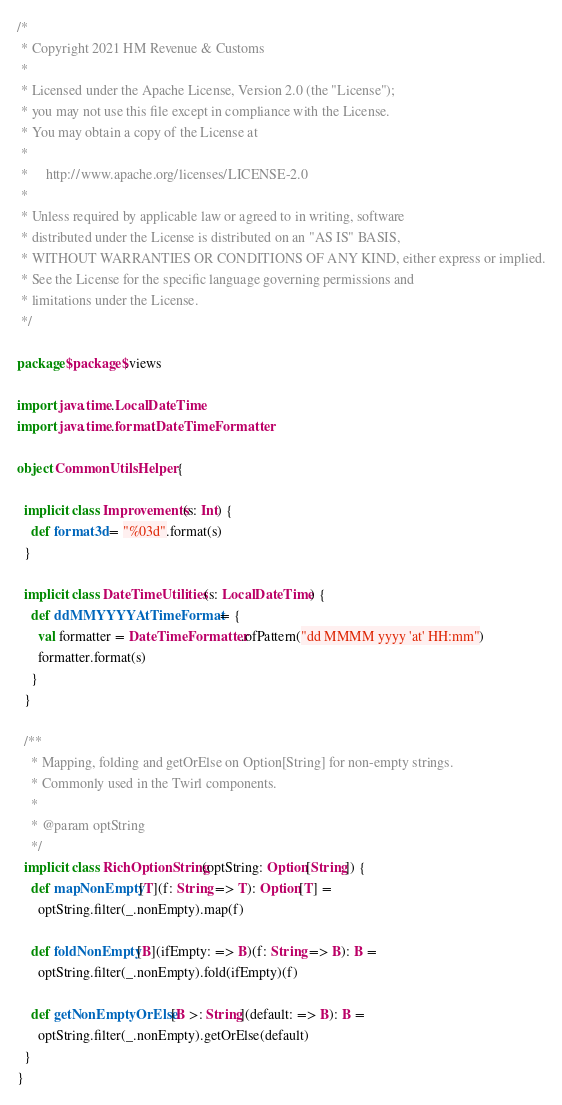Convert code to text. <code><loc_0><loc_0><loc_500><loc_500><_Scala_>/*
 * Copyright 2021 HM Revenue & Customs
 *
 * Licensed under the Apache License, Version 2.0 (the "License");
 * you may not use this file except in compliance with the License.
 * You may obtain a copy of the License at
 *
 *     http://www.apache.org/licenses/LICENSE-2.0
 *
 * Unless required by applicable law or agreed to in writing, software
 * distributed under the License is distributed on an "AS IS" BASIS,
 * WITHOUT WARRANTIES OR CONDITIONS OF ANY KIND, either express or implied.
 * See the License for the specific language governing permissions and
 * limitations under the License.
 */

package $package$.views

import java.time.LocalDateTime
import java.time.format.DateTimeFormatter

object CommonUtilsHelper {

  implicit class Improvements(s: Int) {
    def format3d = "%03d".format(s)
  }

  implicit class DateTimeUtilities(s: LocalDateTime) {
    def ddMMYYYYAtTimeFormat = {
      val formatter = DateTimeFormatter.ofPattern("dd MMMM yyyy 'at' HH:mm")
      formatter.format(s)
    }
  }

  /**
    * Mapping, folding and getOrElse on Option[String] for non-empty strings.
    * Commonly used in the Twirl components.
    *
    * @param optString
    */
  implicit class RichOptionString(optString: Option[String]) {
    def mapNonEmpty[T](f: String => T): Option[T] =
      optString.filter(_.nonEmpty).map(f)

    def foldNonEmpty[B](ifEmpty: => B)(f: String => B): B =
      optString.filter(_.nonEmpty).fold(ifEmpty)(f)

    def getNonEmptyOrElse[B >: String](default: => B): B =
      optString.filter(_.nonEmpty).getOrElse(default)
  }
}
</code> 